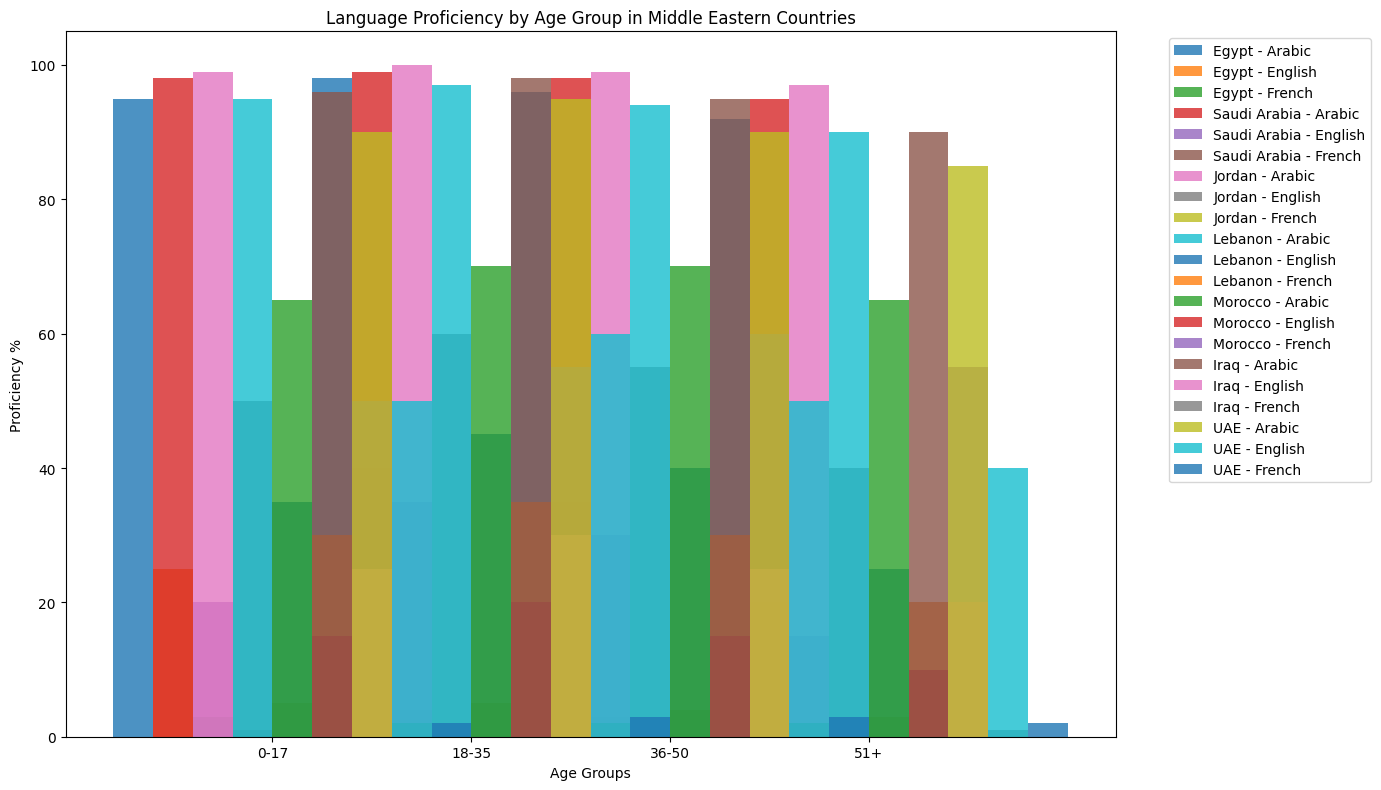Which country has the highest Arabic proficiency in the 18-35 age group? Look at the 18-35 age group for each country and compare the Arabic proficiency. Jordan has 100%, which is the highest.
Answer: Jordan In the 36-50 age group, which country shows the lowest French proficiency? Compare French proficiency percentages in the 36-50 age group across all countries. Saudi Arabia has the lowest with 1%.
Answer: Saudi Arabia What is the average English proficiency in Lebanon across all age groups? Add all the English proficiency percentages for Lebanon (35, 45, 40, 25) and divide by 4. The average is (35 + 45 + 40 + 25) / 4 = 36.25%.
Answer: 36.25% Which age group in Morocco has the highest French proficiency? Compare French proficiency percentages in all age groups in Morocco. The 36-50 age group has the highest with 60%.
Answer: 36-50 Compare the Arabic proficiency of the 0-17 age group between UAE and Saudi Arabia. Which one is higher? Look at the Arabic proficiency percentages for the 0-17 age group in UAE (90%) and Saudi Arabia (98%). Saudi Arabia is higher.
Answer: Saudi Arabia What is the difference in English proficiency between the 18-35 and 51+ age groups in Egypt? Subtract the English proficiency of the 51+ age group in Egypt (20%) from the 18-35 age group (40%). The difference is 40 - 20 = 20%.
Answer: 20% Regarding the visual attributes, which country has bars of similar height for Arabic proficiency across all age groups? Visually inspect the height of the bars for Arabic proficiency across all age groups for each country. Saudi Arabia has bars of similar height for Arabic proficiency.
Answer: Saudi Arabia Which two age groups in Jordan have the same French proficiency percentages? Compare French proficiency percentages of different age groups in Jordan. Both the 0-17 and 18-35 age groups have 5%.
Answer: 0-17 and 18-35 In the 51+ age group, which country shows the lowest English proficiency? Compare English proficiency percentages in the 51+ age group across all countries. Saudi Arabia has the lowest at 15%.
Answer: Saudi Arabia Examine the bar heights for French proficiency in UAE. Are they generally increasing or decreasing with age? Look at the heights of the French proficiency bars in UAE across age groups (0-17: 2%, 18-35: 3%, 36-50: 3%, 51+: 2%). They remain fairly constant, showing slight fluctuations but no clear trend of increasing or decreasing.
Answer: Fluctuating 